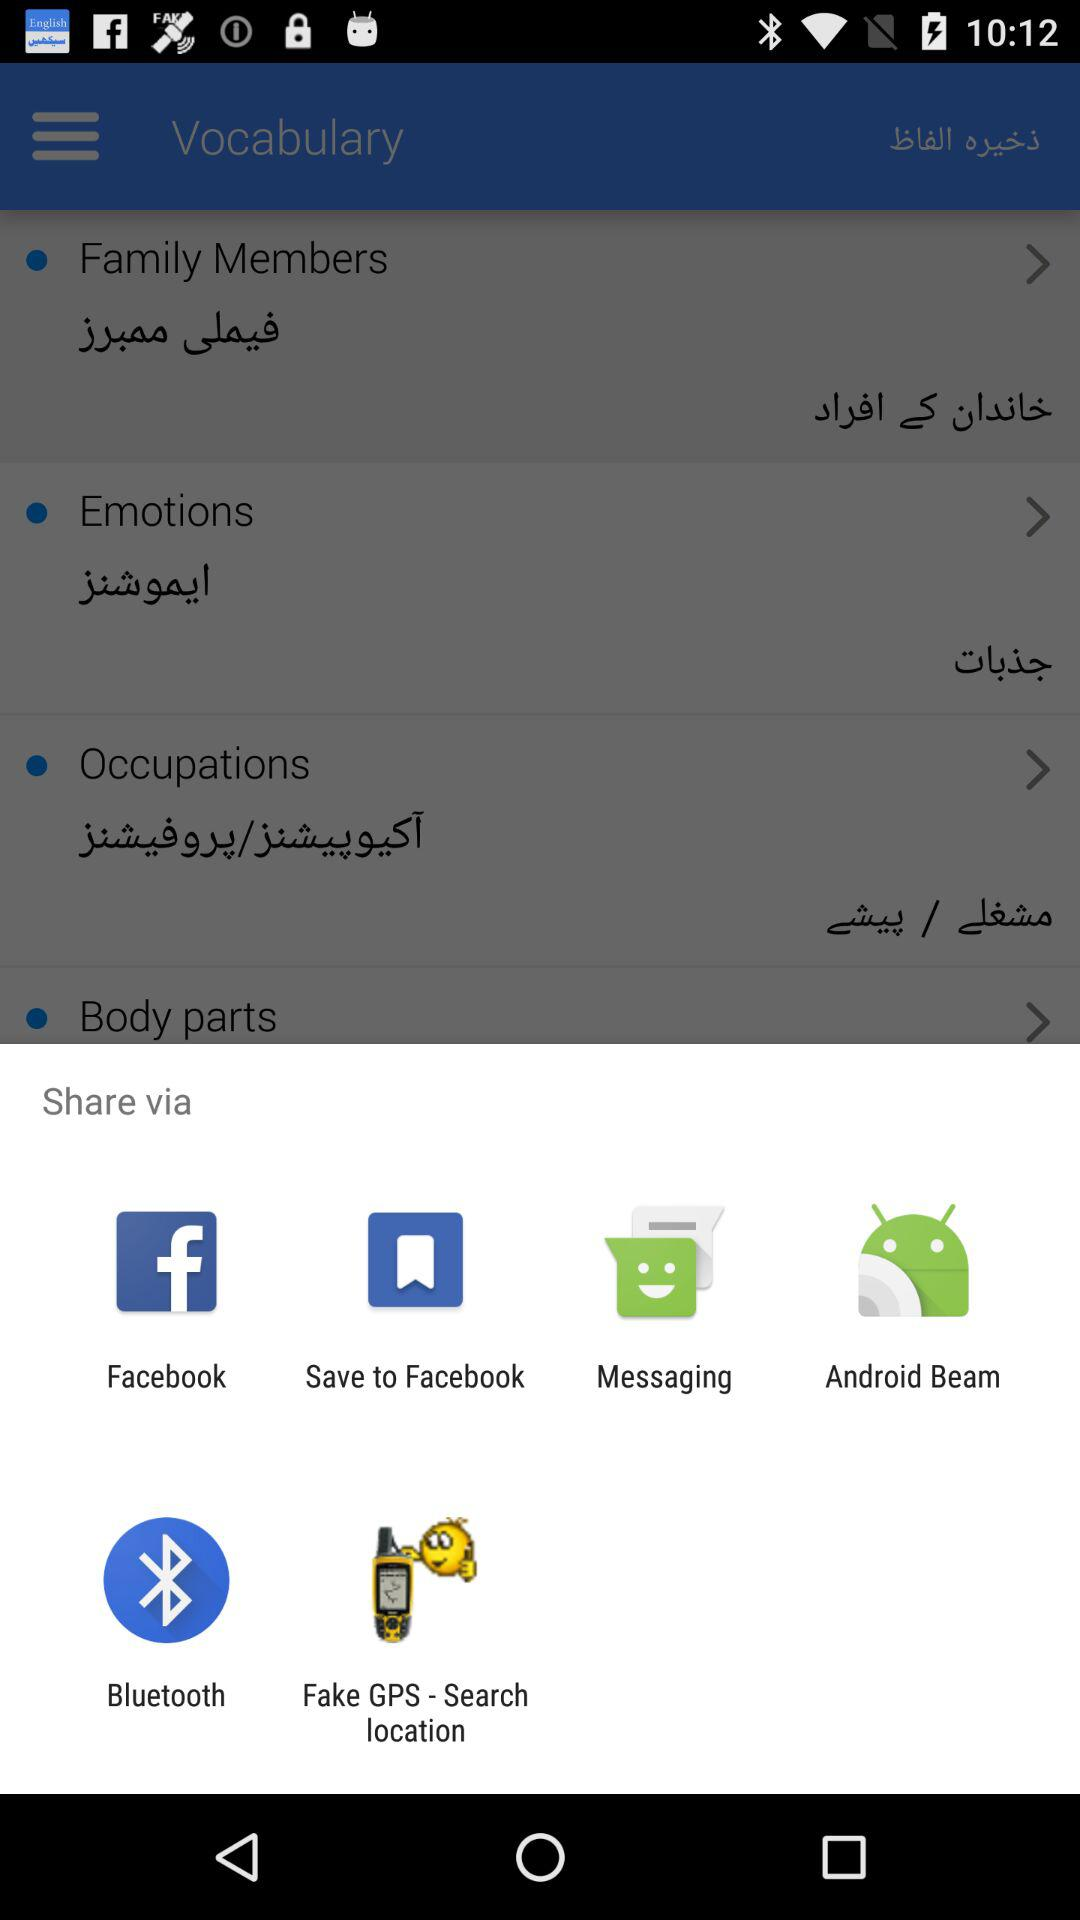Which application can I choose to share the content? You can choose "Facebook", "Messaging", "Android Beam", "Bluetooth" and "Fake GPS - Search location" to share the content. 